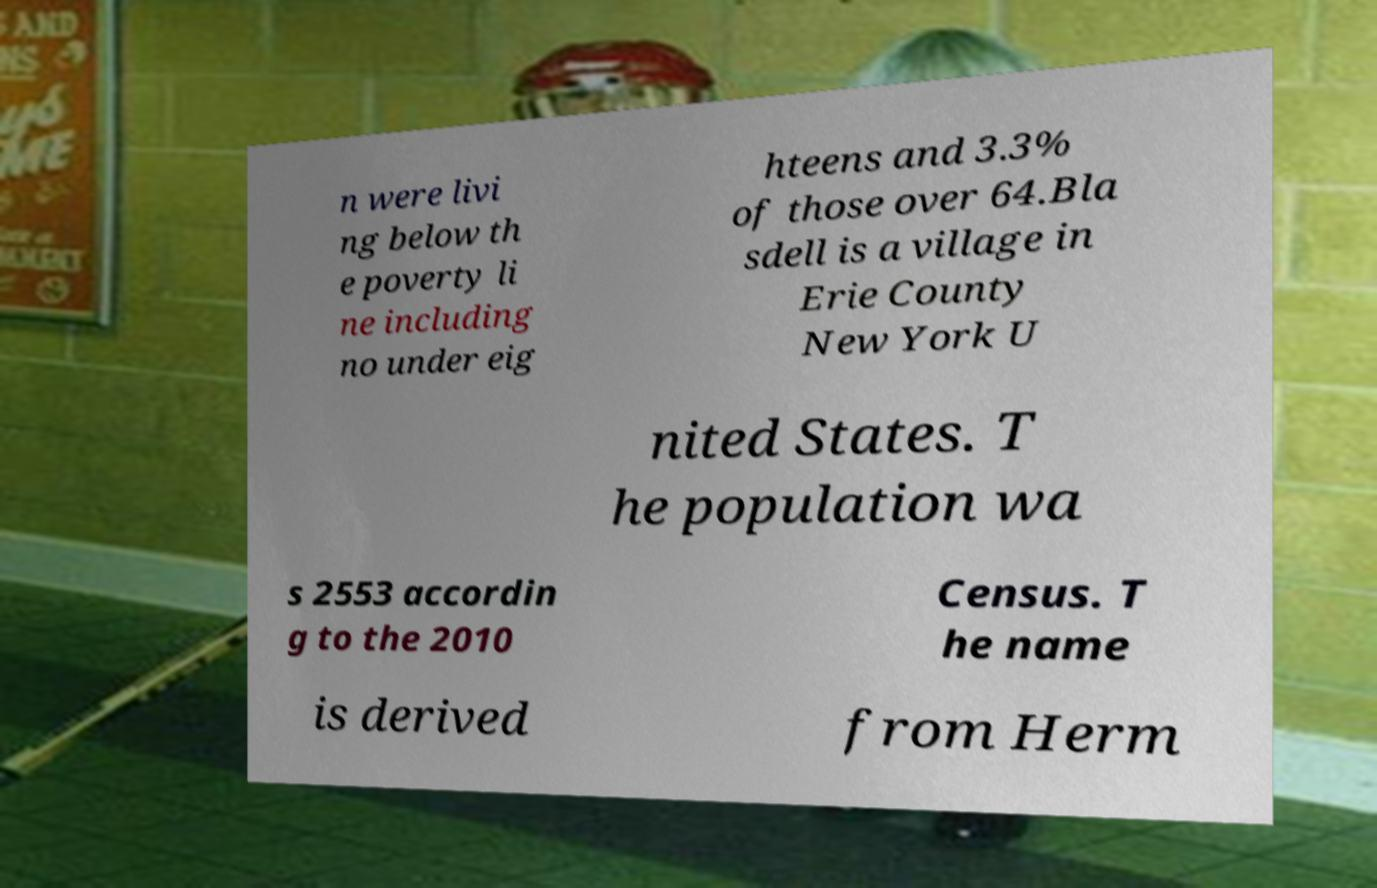Can you read and provide the text displayed in the image?This photo seems to have some interesting text. Can you extract and type it out for me? n were livi ng below th e poverty li ne including no under eig hteens and 3.3% of those over 64.Bla sdell is a village in Erie County New York U nited States. T he population wa s 2553 accordin g to the 2010 Census. T he name is derived from Herm 